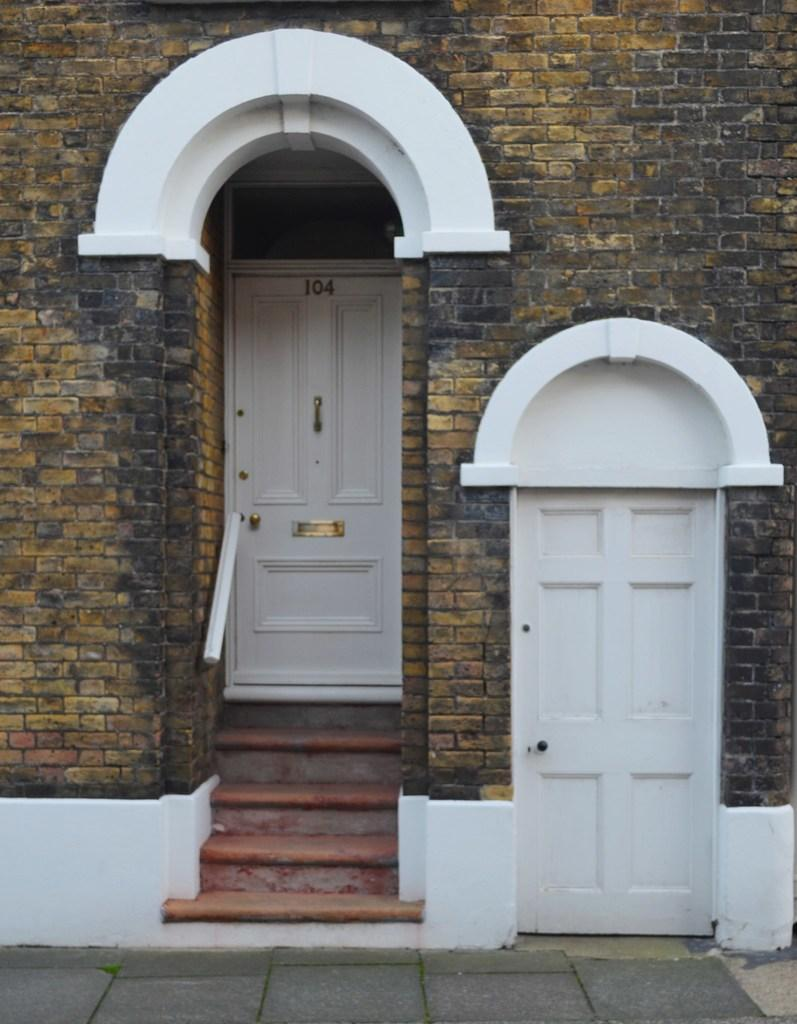What type of structure is visible in the image? There is a building in the image. What can be seen in the foreground of the image? There are doors, a handrail, and a staircase in the foreground of the image. Can you describe any specific details about the doors? There is a number on one of the doors. What is visible at the bottom of the image? There is a floor visible at the bottom of the image. How much profit does the building generate in the image? There is no information about profit in the image; it only shows a building with doors, a handrail, a staircase, and a floor. 